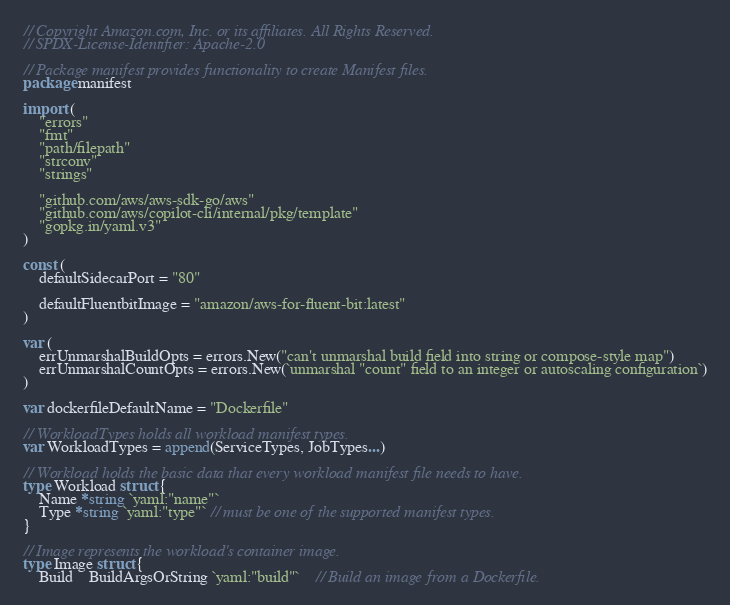<code> <loc_0><loc_0><loc_500><loc_500><_Go_>// Copyright Amazon.com, Inc. or its affiliates. All Rights Reserved.
// SPDX-License-Identifier: Apache-2.0

// Package manifest provides functionality to create Manifest files.
package manifest

import (
	"errors"
	"fmt"
	"path/filepath"
	"strconv"
	"strings"

	"github.com/aws/aws-sdk-go/aws"
	"github.com/aws/copilot-cli/internal/pkg/template"
	"gopkg.in/yaml.v3"
)

const (
	defaultSidecarPort = "80"

	defaultFluentbitImage = "amazon/aws-for-fluent-bit:latest"
)

var (
	errUnmarshalBuildOpts = errors.New("can't unmarshal build field into string or compose-style map")
	errUnmarshalCountOpts = errors.New(`unmarshal "count" field to an integer or autoscaling configuration`)
)

var dockerfileDefaultName = "Dockerfile"

// WorkloadTypes holds all workload manifest types.
var WorkloadTypes = append(ServiceTypes, JobTypes...)

// Workload holds the basic data that every workload manifest file needs to have.
type Workload struct {
	Name *string `yaml:"name"`
	Type *string `yaml:"type"` // must be one of the supported manifest types.
}

// Image represents the workload's container image.
type Image struct {
	Build    BuildArgsOrString `yaml:"build"`    // Build an image from a Dockerfile.</code> 